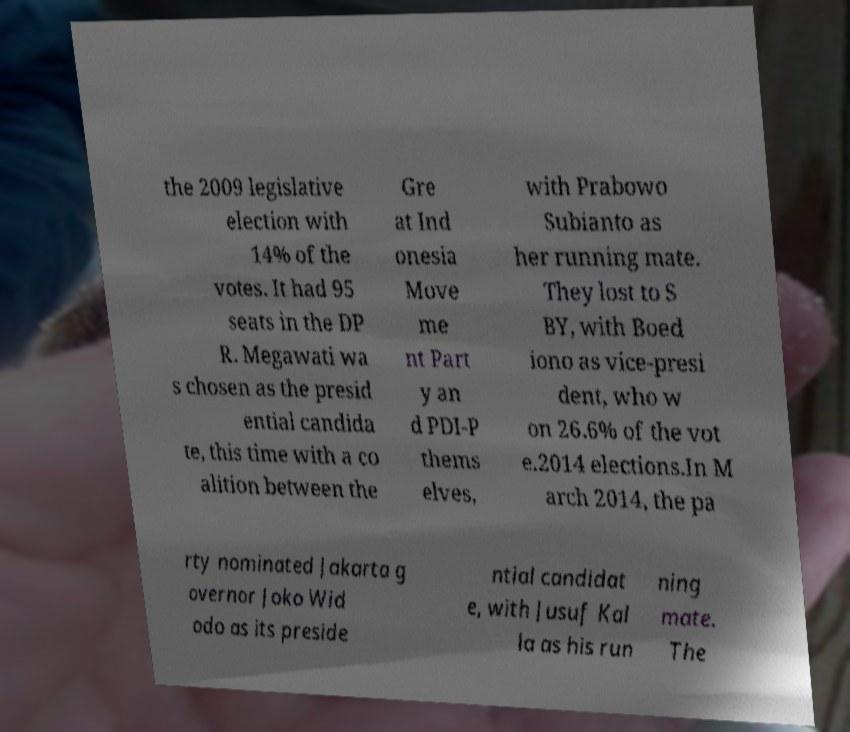Could you extract and type out the text from this image? the 2009 legislative election with 14% of the votes. It had 95 seats in the DP R. Megawati wa s chosen as the presid ential candida te, this time with a co alition between the Gre at Ind onesia Move me nt Part y an d PDI-P thems elves, with Prabowo Subianto as her running mate. They lost to S BY, with Boed iono as vice-presi dent, who w on 26.6% of the vot e.2014 elections.In M arch 2014, the pa rty nominated Jakarta g overnor Joko Wid odo as its preside ntial candidat e, with Jusuf Kal la as his run ning mate. The 